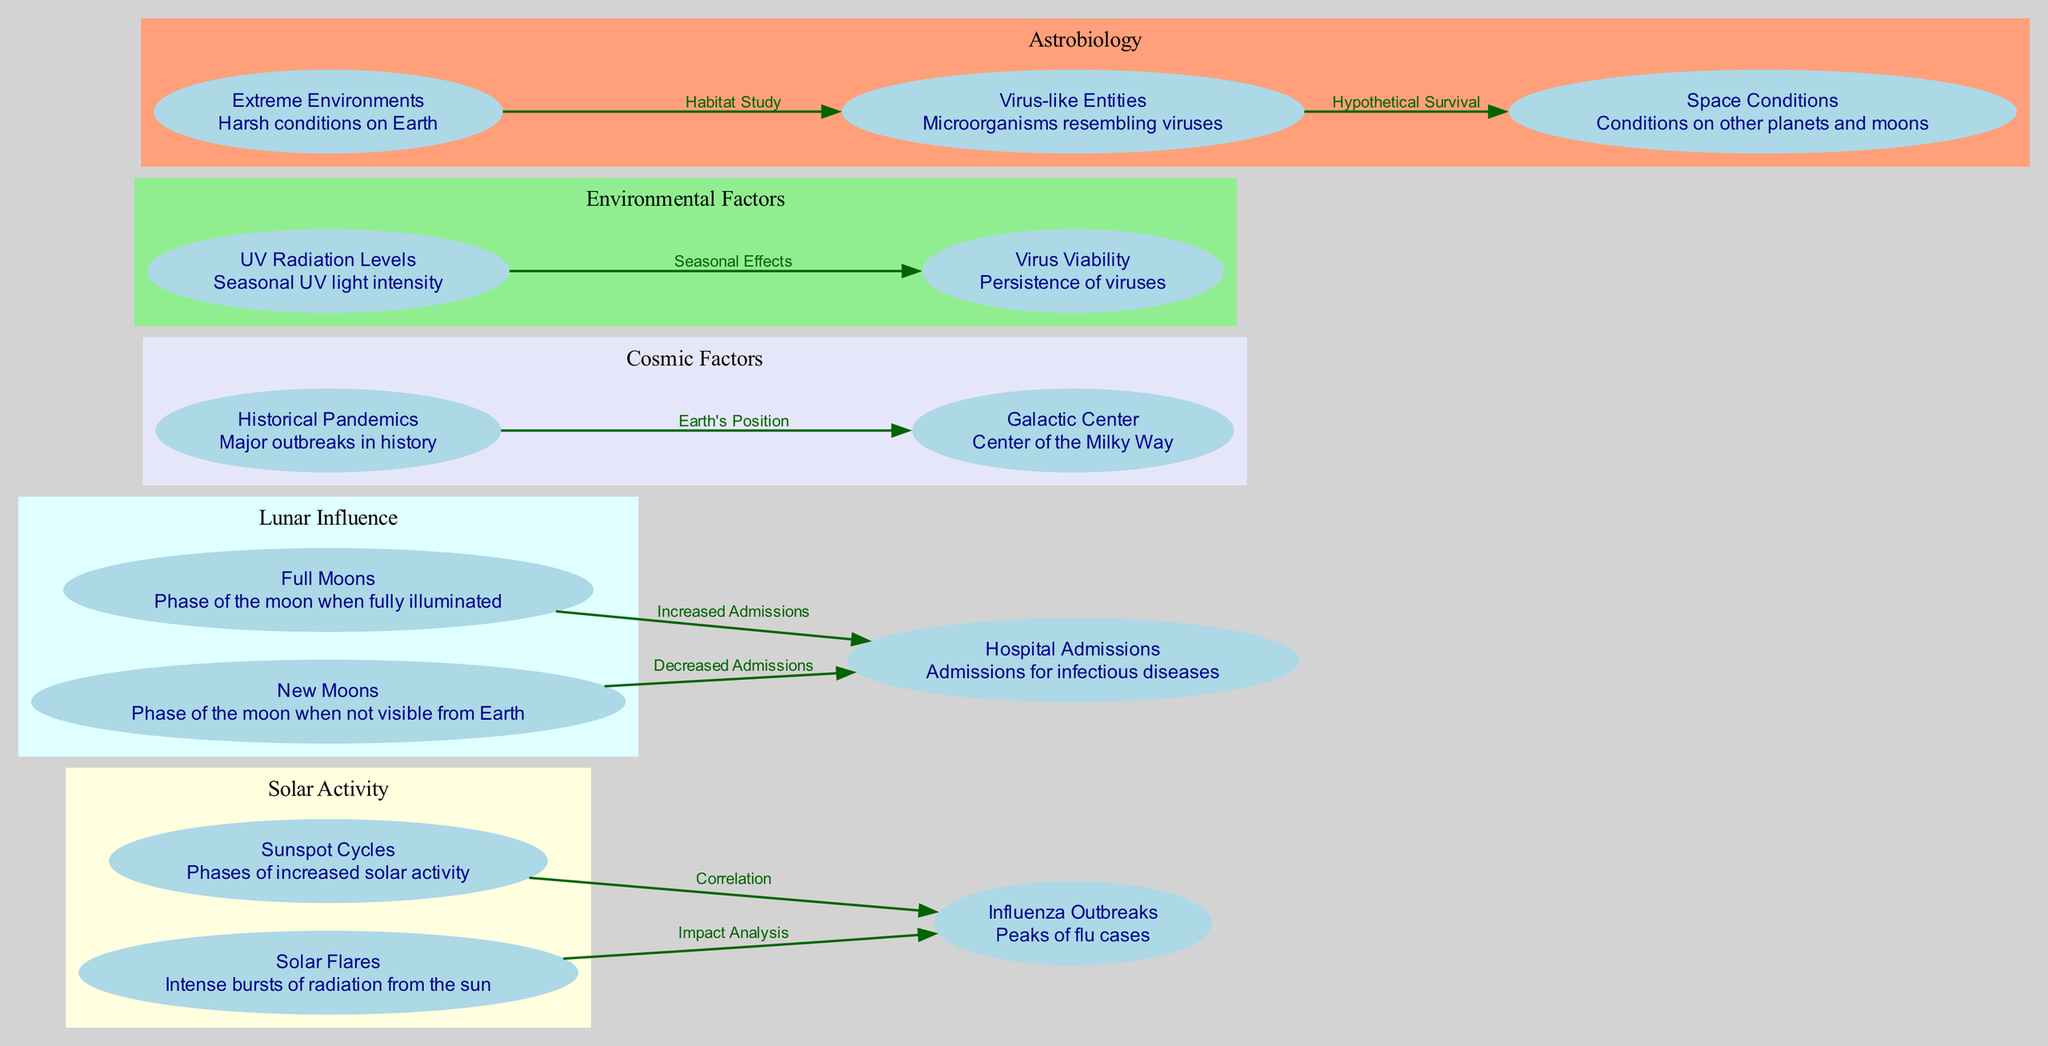What are the two phases of solar activity represented in the diagram? The nodes titled "Sunspot Cycles" and "Solar Flares" represent the two phases of solar activity. They are both part of the cluster labeled "Solar Activity."
Answer: Sunspot Cycles, Solar Flares How many edges are there in the diagram? By counting the connections between the nodes in the diagram, there are a total of 8 edges.
Answer: 8 What is the relationship between Full Moons and Hospital Admissions? The edge connecting "Full Moons" to "Hospital Admissions" indicates an "Increased Admissions" correlation, highlighting a relationship where full moons correspond to a rise in hospital admissions for infectious diseases.
Answer: Increased Admissions During which moon phase are hospital admissions decreased? The diagram shows a direct connection from "New Moons" to "Hospital Admissions," labeling this relationship as "Decreased Admissions," indicating that this phase correlates with a drop in hospital admissions.
Answer: Decreased Admissions What is the significance of Earth's position to Historical Pandemics? The edge from "Historical Pandemics" to "Galactic Center" is labeled "Earth's Position," indicating the diagram is illustrating a relationship suggesting that Earth's alignment with the Galactic Center may have implications during significant pandemic events throughout history.
Answer: Earth's Position Which node is related to seasonal UV radiation levels? "UV Radiation Levels" is labeled in the diagram as related to seasonal intensity, and it connects to "Virus Viability," showing the impact of UV light on virus persistence.
Answer: UV Radiation Levels How do Extreme Environments relate to Virus-like Entities? The connection labeled "Habitat Study" between "Extreme Environments" and "Virus-like Entities" indicates that the diagram explores how harsh conditions on Earth provide habitats for microorganisms resembling viruses.
Answer: Habitat Study What influences the persistence of viruses according to the diagram? The edge labeled "Seasonal Effects" from "UV Radiation Levels" to "Virus Viability" indicates that seasonal variations in UV radiation significantly influence the persistence of viruses.
Answer: Seasonal Effects 